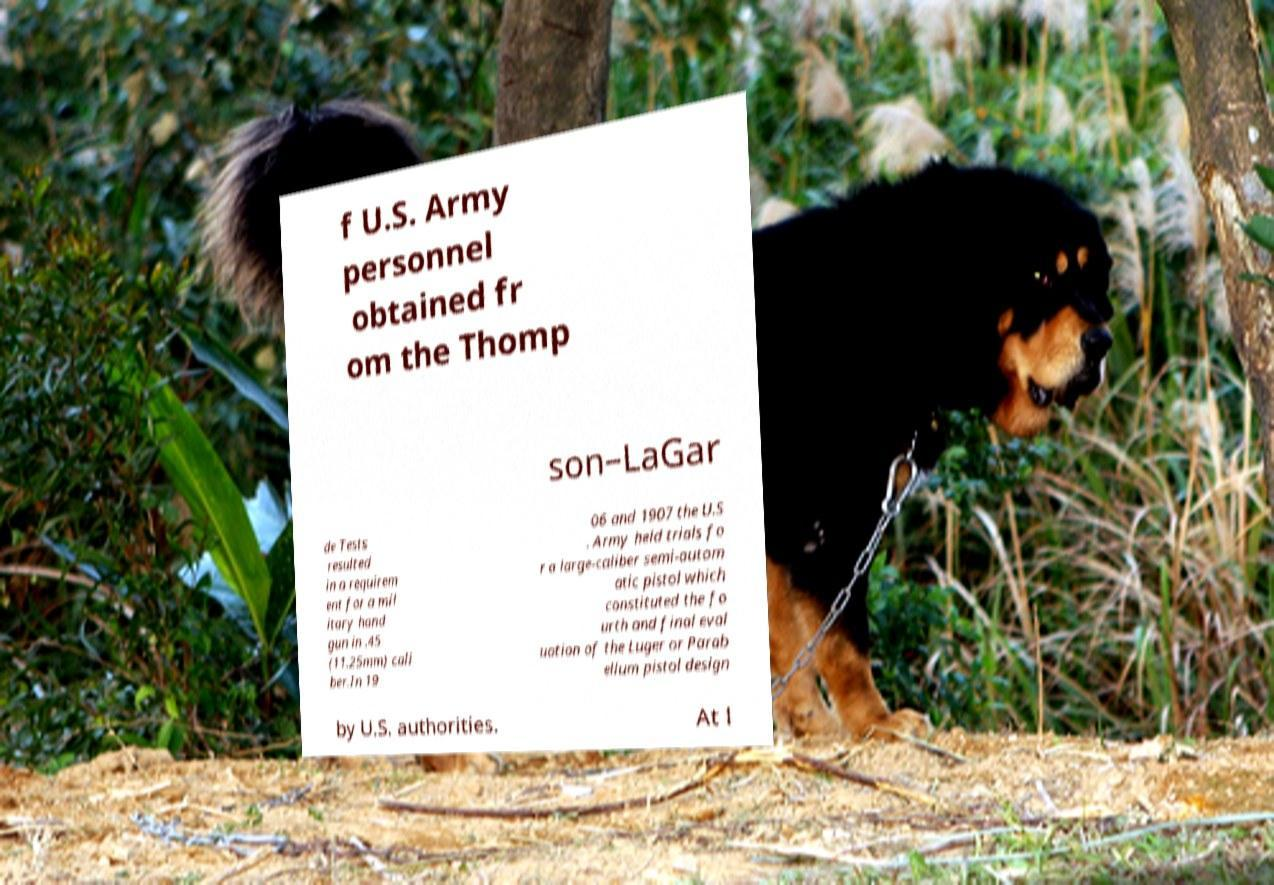Can you read and provide the text displayed in the image?This photo seems to have some interesting text. Can you extract and type it out for me? f U.S. Army personnel obtained fr om the Thomp son–LaGar de Tests resulted in a requirem ent for a mil itary hand gun in .45 (11.25mm) cali ber.In 19 06 and 1907 the U.S . Army held trials fo r a large-caliber semi-autom atic pistol which constituted the fo urth and final eval uation of the Luger or Parab ellum pistol design by U.S. authorities. At l 